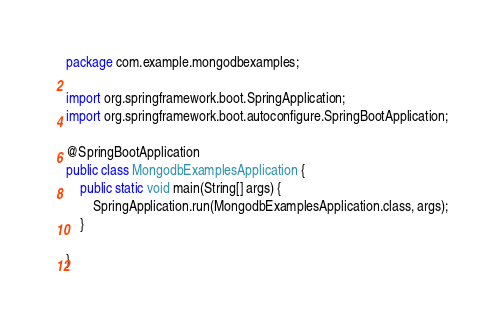<code> <loc_0><loc_0><loc_500><loc_500><_Java_>package com.example.mongodbexamples;

import org.springframework.boot.SpringApplication;
import org.springframework.boot.autoconfigure.SpringBootApplication;

@SpringBootApplication
public class MongodbExamplesApplication {
    public static void main(String[] args) {
        SpringApplication.run(MongodbExamplesApplication.class, args);
    }

}
</code> 